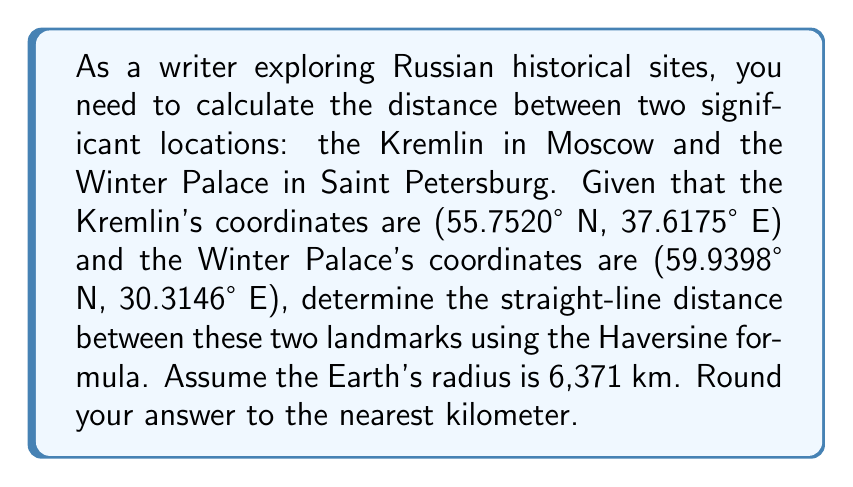Give your solution to this math problem. To solve this problem, we'll use the Haversine formula, which calculates the great-circle distance between two points on a sphere given their longitudes and latitudes. Let's break it down step-by-step:

1. Convert the coordinates from degrees to radians:
   $$\text{lat}_1 = 55.7520° \times \frac{\pi}{180} = 0.9731 \text{ rad}$$
   $$\text{lon}_1 = 37.6175° \times \frac{\pi}{180} = 0.6564 \text{ rad}$$
   $$\text{lat}_2 = 59.9398° \times \frac{\pi}{180} = 1.0461 \text{ rad}$$
   $$\text{lon}_2 = 30.3146° \times \frac{\pi}{180} = 0.5290 \text{ rad}$$

2. Calculate the differences in latitude and longitude:
   $$\Delta\text{lat} = \text{lat}_2 - \text{lat}_1 = 1.0461 - 0.9731 = 0.0730 \text{ rad}$$
   $$\Delta\text{lon} = \text{lon}_2 - \text{lon}_1 = 0.5290 - 0.6564 = -0.1274 \text{ rad}$$

3. Apply the Haversine formula:
   $$a = \sin^2(\frac{\Delta\text{lat}}{2}) + \cos(\text{lat}_1) \times \cos(\text{lat}_2) \times \sin^2(\frac{\Delta\text{lon}}{2})$$
   
   $$c = 2 \times \arctan2(\sqrt{a}, \sqrt{1-a})$$
   
   $$d = R \times c$$

   Where $R$ is the Earth's radius (6,371 km).

4. Calculate $a$:
   $$a = \sin^2(0.0365) + \cos(0.9731) \times \cos(1.0461) \times \sin^2(-0.0637)$$
   $$a = 0.001331 + 0.5531 \times 0.4925 \times 0.004056 = 0.002323$$

5. Calculate $c$:
   $$c = 2 \times \arctan2(\sqrt{0.002323}, \sqrt{1-0.002323}) = 0.09632$$

6. Calculate the distance $d$:
   $$d = 6371 \times 0.09632 = 613.61 \text{ km}$$

7. Round to the nearest kilometer:
   $$d \approx 614 \text{ km}$$
Answer: 614 km 